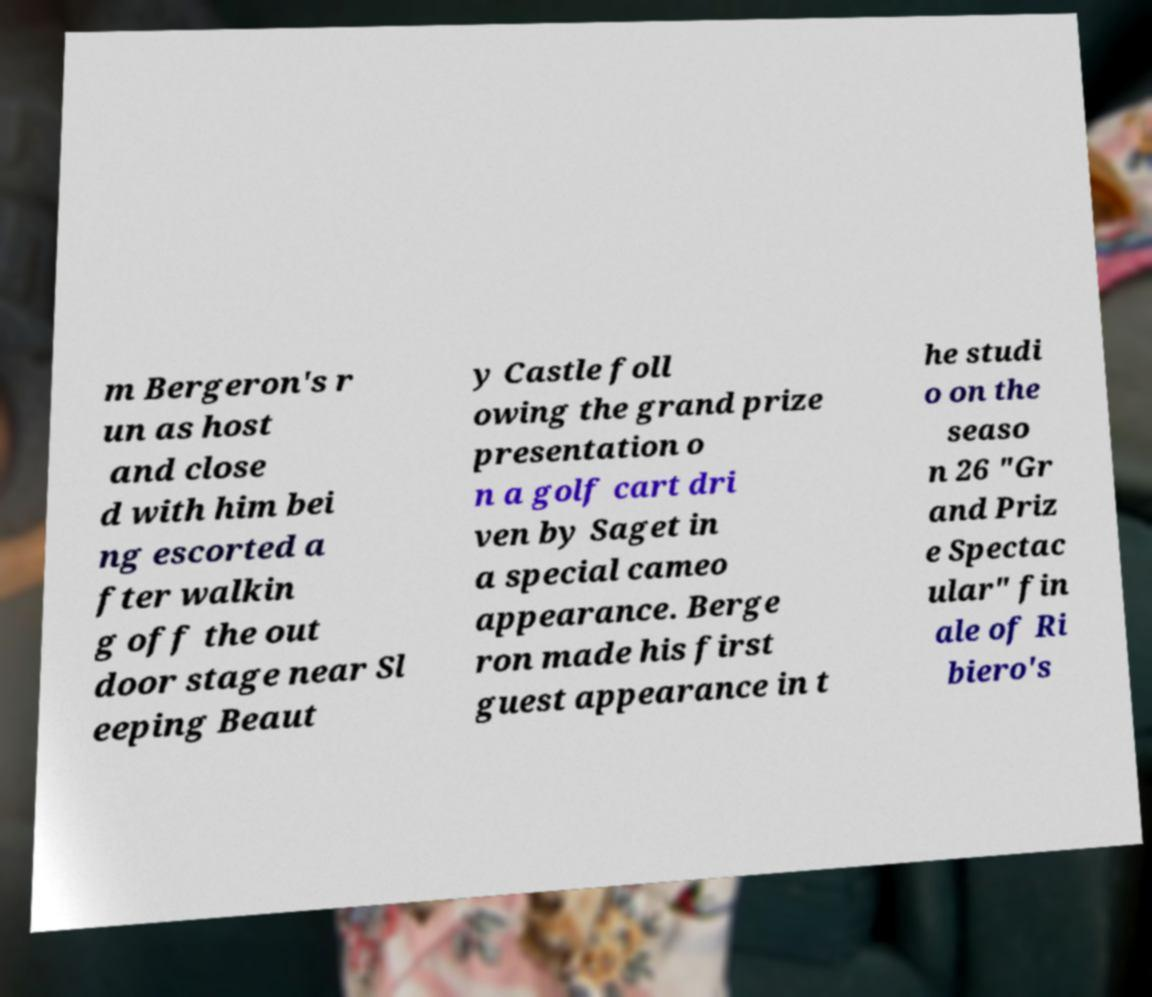Could you extract and type out the text from this image? m Bergeron's r un as host and close d with him bei ng escorted a fter walkin g off the out door stage near Sl eeping Beaut y Castle foll owing the grand prize presentation o n a golf cart dri ven by Saget in a special cameo appearance. Berge ron made his first guest appearance in t he studi o on the seaso n 26 "Gr and Priz e Spectac ular" fin ale of Ri biero's 